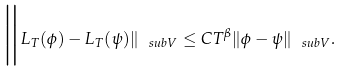Convert formula to latex. <formula><loc_0><loc_0><loc_500><loc_500>\Big \| L _ { T } ( \phi ) - L _ { T } ( \psi ) \| _ { \ s u b V } \leq C T ^ { \beta } \| \phi - \psi \| _ { \ s u b V } .</formula> 